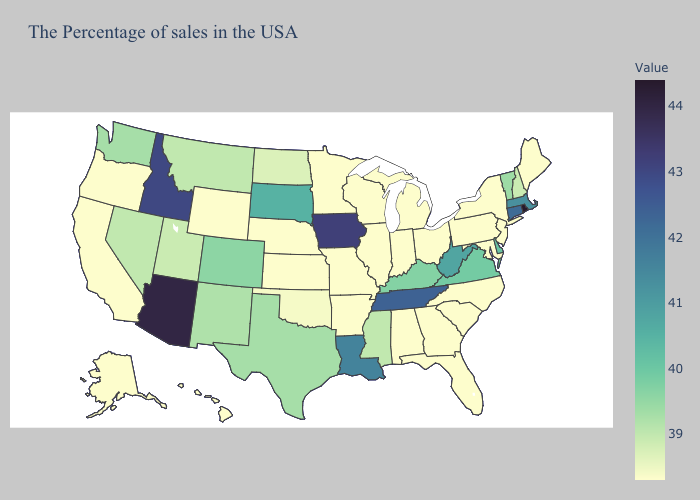Does the map have missing data?
Answer briefly. No. Which states have the lowest value in the South?
Short answer required. Maryland, North Carolina, South Carolina, Florida, Georgia, Alabama, Arkansas. Does Rhode Island have the highest value in the USA?
Answer briefly. Yes. Does Alaska have a lower value than Idaho?
Keep it brief. Yes. 